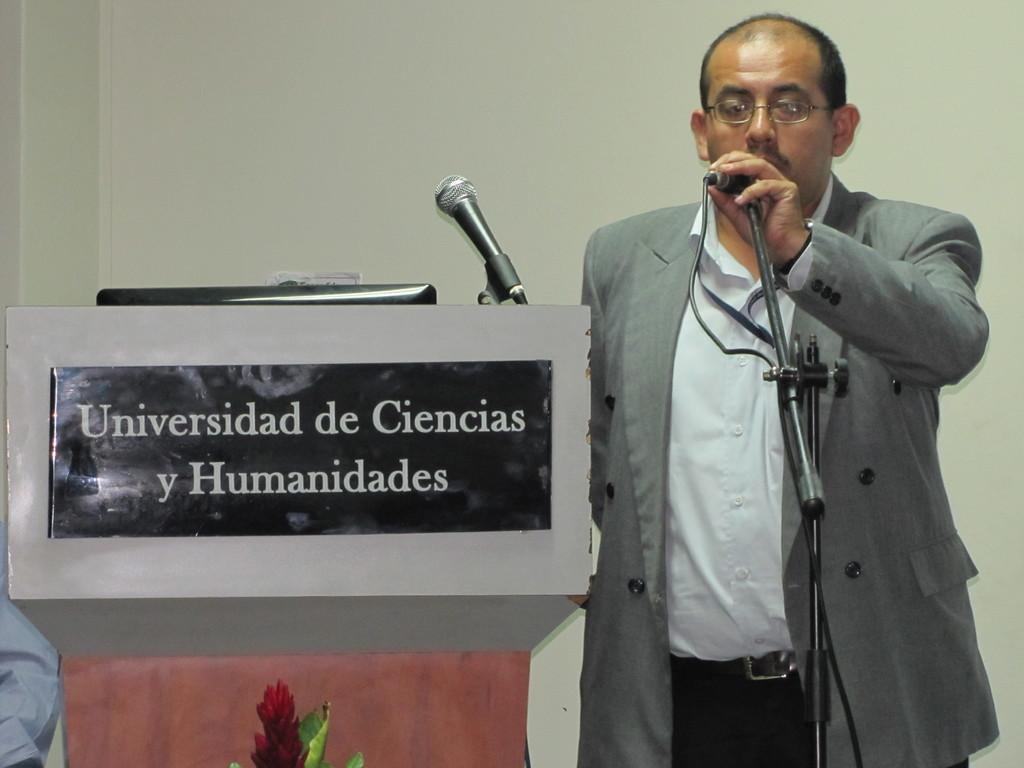In one or two sentences, can you explain what this image depicts? In this image i can see a man standing holding a micro phone, at the left there is a podium and the micro phone at the back ground there is a wall. 